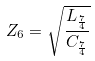<formula> <loc_0><loc_0><loc_500><loc_500>Z _ { 6 } = \sqrt { \frac { L _ { \frac { 7 } { 4 } } } { C _ { \frac { 7 } { 4 } } } }</formula> 